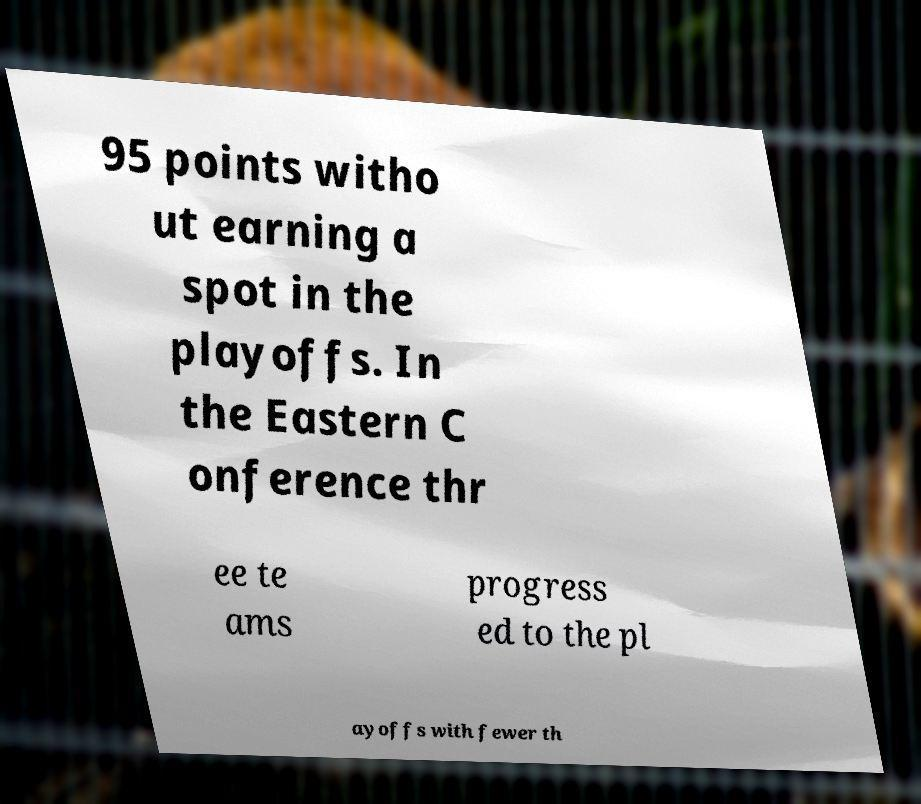I need the written content from this picture converted into text. Can you do that? 95 points witho ut earning a spot in the playoffs. In the Eastern C onference thr ee te ams progress ed to the pl ayoffs with fewer th 